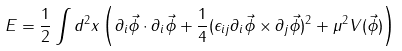<formula> <loc_0><loc_0><loc_500><loc_500>E = \frac { 1 } { 2 } \int d ^ { 2 } x \left ( \partial _ { i } \vec { \phi } \cdot \partial _ { i } \vec { \phi } + \frac { 1 } { 4 } ( \epsilon _ { i j } \partial _ { i } \vec { \phi } \times \partial _ { j } \vec { \phi } ) ^ { 2 } + \mu ^ { 2 } V ( \vec { \phi } ) \right )</formula> 